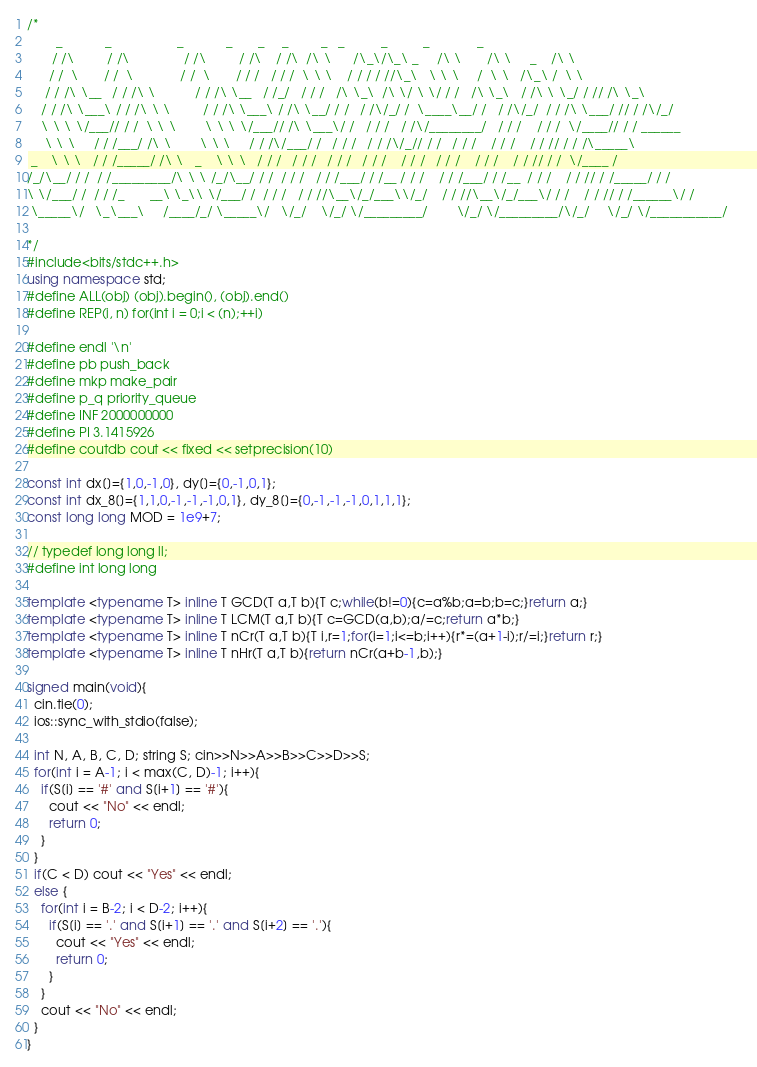<code> <loc_0><loc_0><loc_500><loc_500><_C++_>/*
        _            _                  _            _       _     _         _   _          _          _             _        
       / /\         / /\               / /\         / /\    / /\  /\ \      /\_\/\_\ _     /\ \       /\ \     _    /\ \      
      / /  \       / /  \             / /  \       / / /   / / /  \ \ \    / / / / //\_\   \ \ \     /  \ \   /\_\ /  \ \     
     / / /\ \__   / / /\ \           / / /\ \__   / /_/   / / /   /\ \_\  /\ \/ \ \/ / /   /\ \_\   / /\ \ \_/ / // /\ \_\    
    / / /\ \___\ / / /\ \ \         / / /\ \___\ / /\ \__/ / /   / /\/_/ /  \____\__/ /   / /\/_/  / / /\ \___/ // / /\/_/    
    \ \ \ \/___// / /  \ \ \        \ \ \ \/___// /\ \___\/ /   / / /   / /\/________/   / / /    / / /  \/____// / / ______  
     \ \ \     / / /___/ /\ \        \ \ \     / / /\/___/ /   / / /   / / /\/_// / /   / / /    / / /    / / // / / /\_____\ 
 _    \ \ \   / / /_____/ /\ \   _    \ \ \   / / /   / / /   / / /   / / /    / / /   / / /    / / /    / / // / /  \/____ / 
/_/\__/ / /  / /_________/\ \ \ /_/\__/ / /  / / /   / / /___/ / /__ / / /    / / /___/ / /__  / / /    / / // / /_____/ / /  
\ \/___/ /  / / /_       __\ \_\\ \/___/ /  / / /   / / //\__\/_/___\\/_/    / / //\__\/_/___\/ / /    / / // / /______\/ /   
 \_____\/   \_\___\     /____/_/ \_____\/   \/_/    \/_/ \/_________/        \/_/ \/_________/\/_/     \/_/ \/___________/    
                                                                                                                              
*/
#include<bits/stdc++.h>
using namespace std;
#define ALL(obj) (obj).begin(), (obj).end()
#define REP(i, n) for(int i = 0;i < (n);++i)

#define endl '\n'
#define pb push_back
#define mkp make_pair
#define p_q priority_queue
#define INF 2000000000
#define PI 3.1415926
#define coutdb cout << fixed << setprecision(10)

const int dx[]={1,0,-1,0}, dy[]={0,-1,0,1};
const int dx_8[]={1,1,0,-1,-1,-1,0,1}, dy_8[]={0,-1,-1,-1,0,1,1,1};
const long long MOD = 1e9+7;

// typedef long long ll;
#define int long long

template <typename T> inline T GCD(T a,T b){T c;while(b!=0){c=a%b;a=b;b=c;}return a;}
template <typename T> inline T LCM(T a,T b){T c=GCD(a,b);a/=c;return a*b;}
template <typename T> inline T nCr(T a,T b){T i,r=1;for(i=1;i<=b;i++){r*=(a+1-i);r/=i;}return r;}
template <typename T> inline T nHr(T a,T b){return nCr(a+b-1,b);}

signed main(void){
  cin.tie(0);
  ios::sync_with_stdio(false);

  int N, A, B, C, D; string S; cin>>N>>A>>B>>C>>D>>S;
  for(int i = A-1; i < max(C, D)-1; i++){
    if(S[i] == '#' and S[i+1] == '#'){
      cout << "No" << endl;
      return 0;
    }
  }
  if(C < D) cout << "Yes" << endl;
  else {
    for(int i = B-2; i < D-2; i++){
      if(S[i] == '.' and S[i+1] == '.' and S[i+2] == '.'){
        cout << "Yes" << endl;
        return 0;
      }
    }
    cout << "No" << endl;
  }
}</code> 